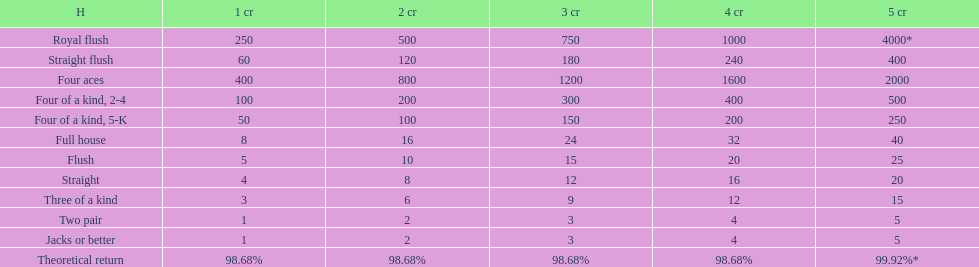Would you be able to parse every entry in this table? {'header': ['H', '1 cr', '2 cr', '3 cr', '4 cr', '5 cr'], 'rows': [['Royal flush', '250', '500', '750', '1000', '4000*'], ['Straight flush', '60', '120', '180', '240', '400'], ['Four aces', '400', '800', '1200', '1600', '2000'], ['Four of a kind, 2-4', '100', '200', '300', '400', '500'], ['Four of a kind, 5-K', '50', '100', '150', '200', '250'], ['Full house', '8', '16', '24', '32', '40'], ['Flush', '5', '10', '15', '20', '25'], ['Straight', '4', '8', '12', '16', '20'], ['Three of a kind', '3', '6', '9', '12', '15'], ['Two pair', '1', '2', '3', '4', '5'], ['Jacks or better', '1', '2', '3', '4', '5'], ['Theoretical return', '98.68%', '98.68%', '98.68%', '98.68%', '99.92%*']]} Which is a higher standing hand: a straight or a flush? Flush. 